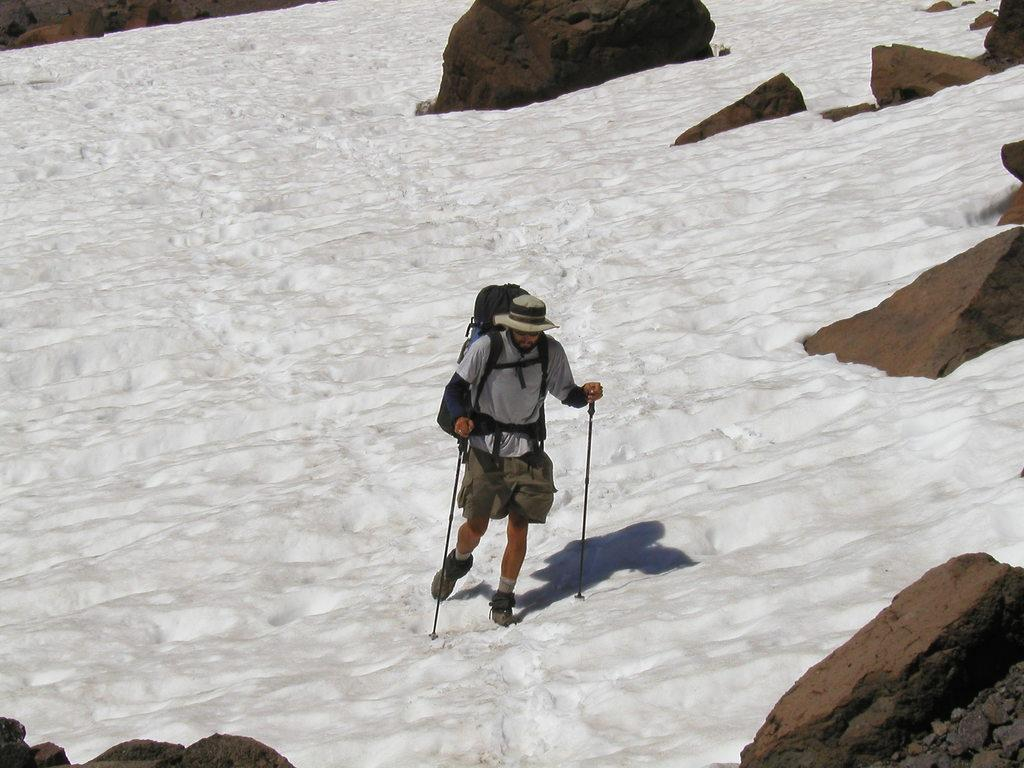Who is present in the image? There is a man in the image. What is the man wearing on his back? The man is wearing a backpack. What is the man wearing on his head? The man is wearing a hat. What is the man holding in his hands? The man is holding sticks in his hands. What type of terrain is the man walking on? The man is walking on the snow. What other objects can be seen in the image? There are rocks in the image. What type of farm animals can be seen in the image? There are no farm animals present in the image. What is the man eating for breakfast in the image? There is no indication of the man eating breakfast in the image. 